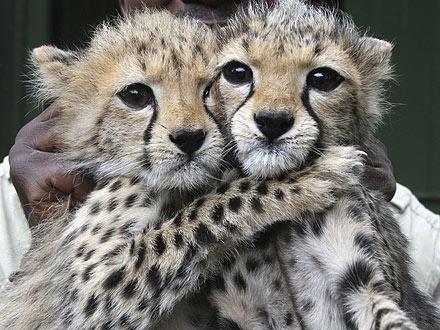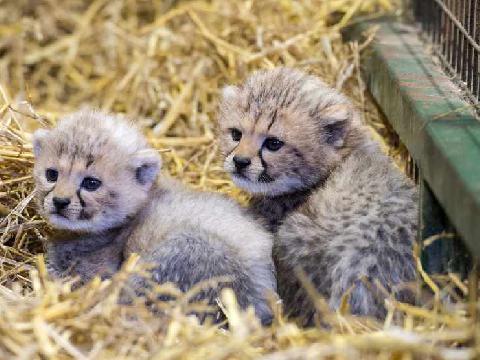The first image is the image on the left, the second image is the image on the right. Examine the images to the left and right. Is the description "One image shows at least two cheetah kittens to the left of an adult cheetah's face." accurate? Answer yes or no. No. The first image is the image on the left, the second image is the image on the right. For the images shown, is this caption "The right image contains exactly two baby cheetahs." true? Answer yes or no. Yes. 